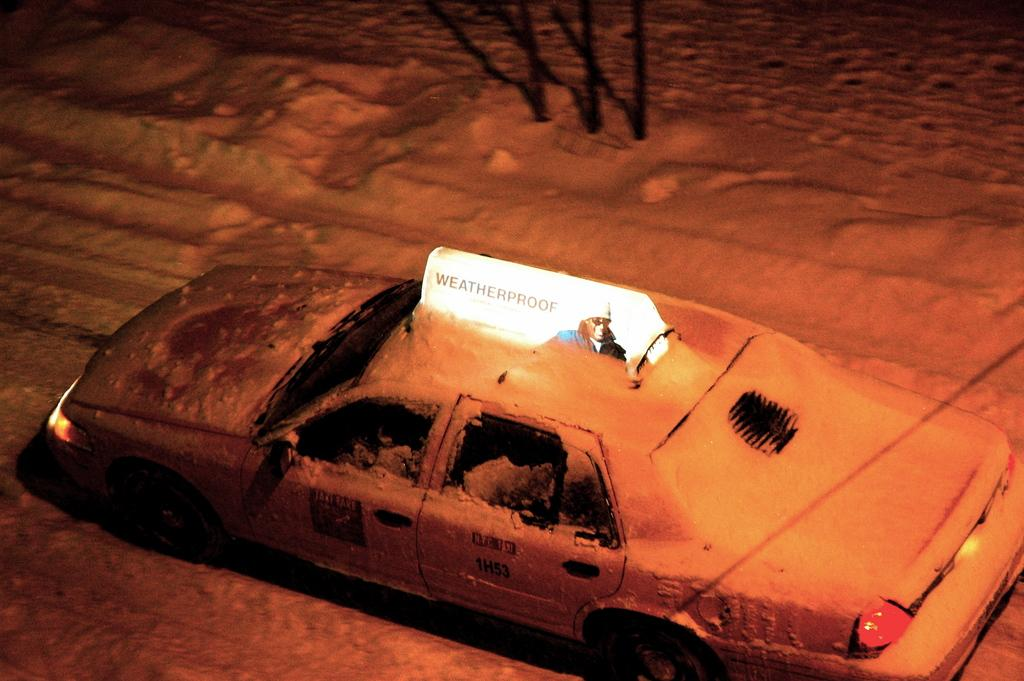Provide a one-sentence caption for the provided image. a cab that has the name weatherproof at the top of it. 